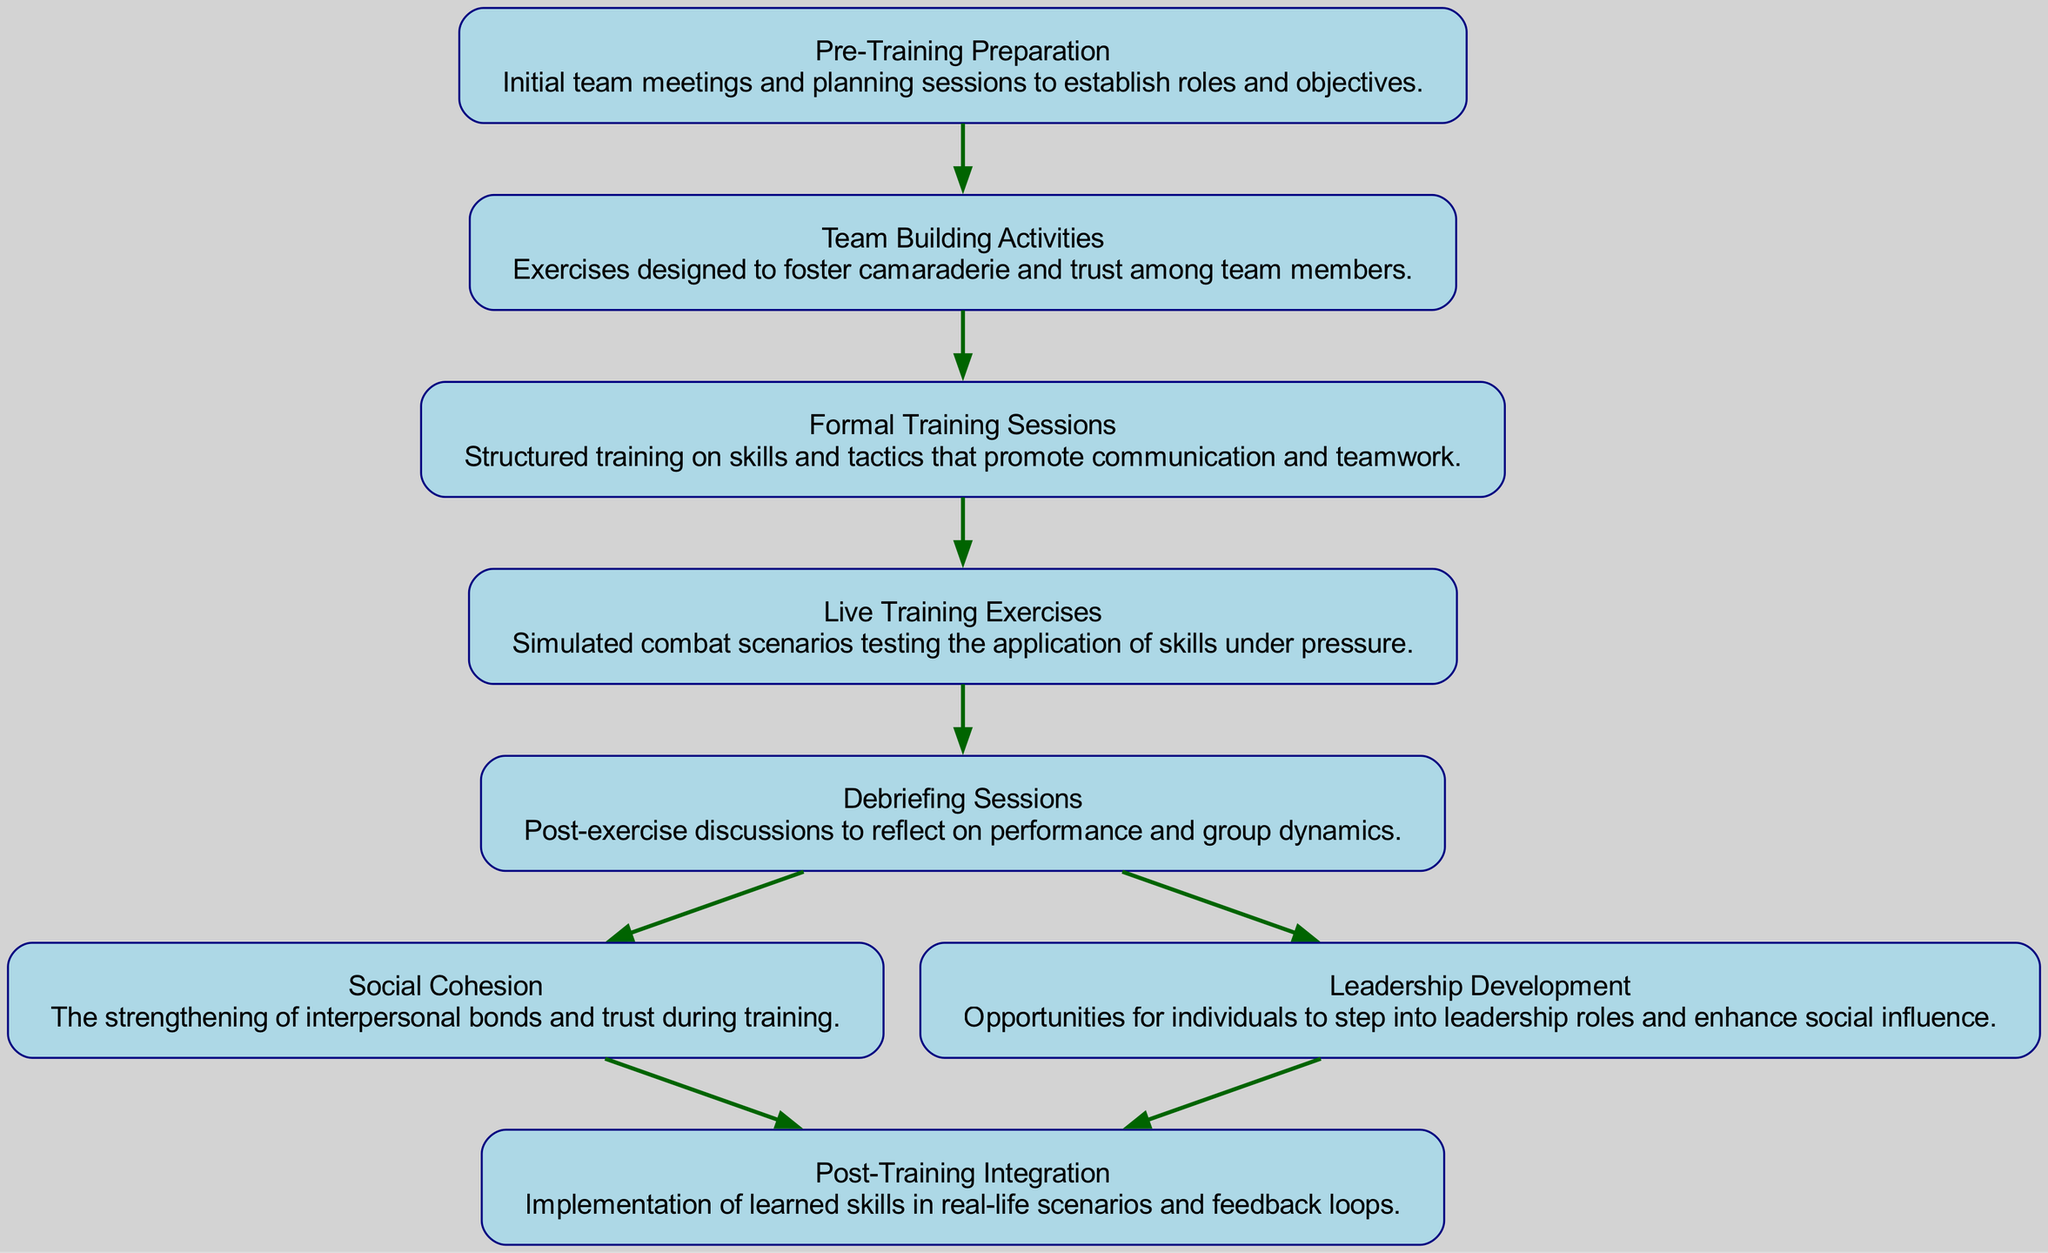What is the first node in the training process? The first node in the training process is "Pre-Training Preparation". This is established as the starting point in the directed graph, clearly labeled at the top of the flow.
Answer: Pre-Training Preparation How many nodes are represented in this diagram? To find the total number of nodes, we can count each unique label listed in the nodes section of the data. There are eight nodes in total.
Answer: 8 Which node is connected to "Live Training Exercises"? The node that is directly connected to "Live Training Exercises" is "Debriefing Sessions". In the diagram, there is a directed edge that indicates this connection.
Answer: Debriefing Sessions What social aspect is enhanced by "Debriefing Sessions"? "Debriefing Sessions" leads to the enhancement of both "Social Cohesion" and "Leadership Development", as indicated by the directed connections out of this node.
Answer: Social Cohesion and Leadership Development Which training activity precedes "Formal Training Sessions"? The training activity that precedes "Formal Training Sessions" is "Team Building Activities", which is the direct parent node in the flow of the training process depicted in the diagram.
Answer: Team Building Activities What is the relationship between "Social Cohesion" and "Post-Training Integration"? "Social Cohesion" is connected to "Post-Training Integration" through a directed edge, indicating that the strengthening of interpersonal bonds during training contributes positively to the implementation of learned skills afterward.
Answer: Contributes positively How many edges are present in the entire diagram? To determine the number of edges, count all the directed connections between the nodes as presented in the edges section. There are seven edges in total.
Answer: 7 What is the role of "Leadership Development" in the training process? "Leadership Development" provides opportunities for individuals to enhance their social influence and step into leadership roles. It connects to "Post-Training Integration", showing its influence on real-life application of the training.
Answer: Enhance social influence Which nodes lead to the "Post-Training Integration"? Both "Social Cohesion" and "Leadership Development" lead to "Post-Training Integration". This indicates that both elements play significant roles in applying the skills learned during the training.
Answer: Social Cohesion and Leadership Development 